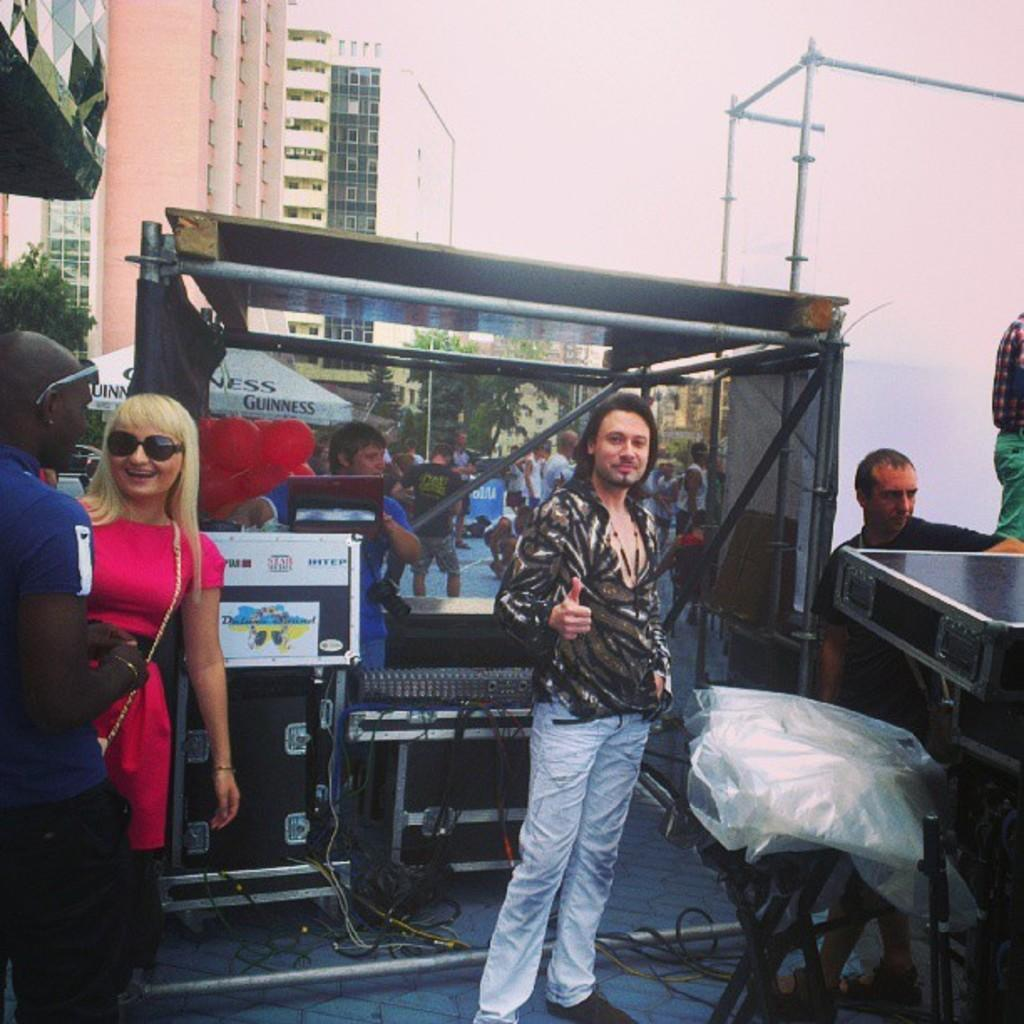What is happening in the image involving people? There are people standing in the image. What objects are present that are related to music? There are musical instruments in the image. What can be seen in the distance behind the people and instruments? There are buildings in the background of the image. What is visible at the top of the image? The sky is visible at the top of the image. How many apples are being held by the women in the image? There are no women or apples present in the image. 